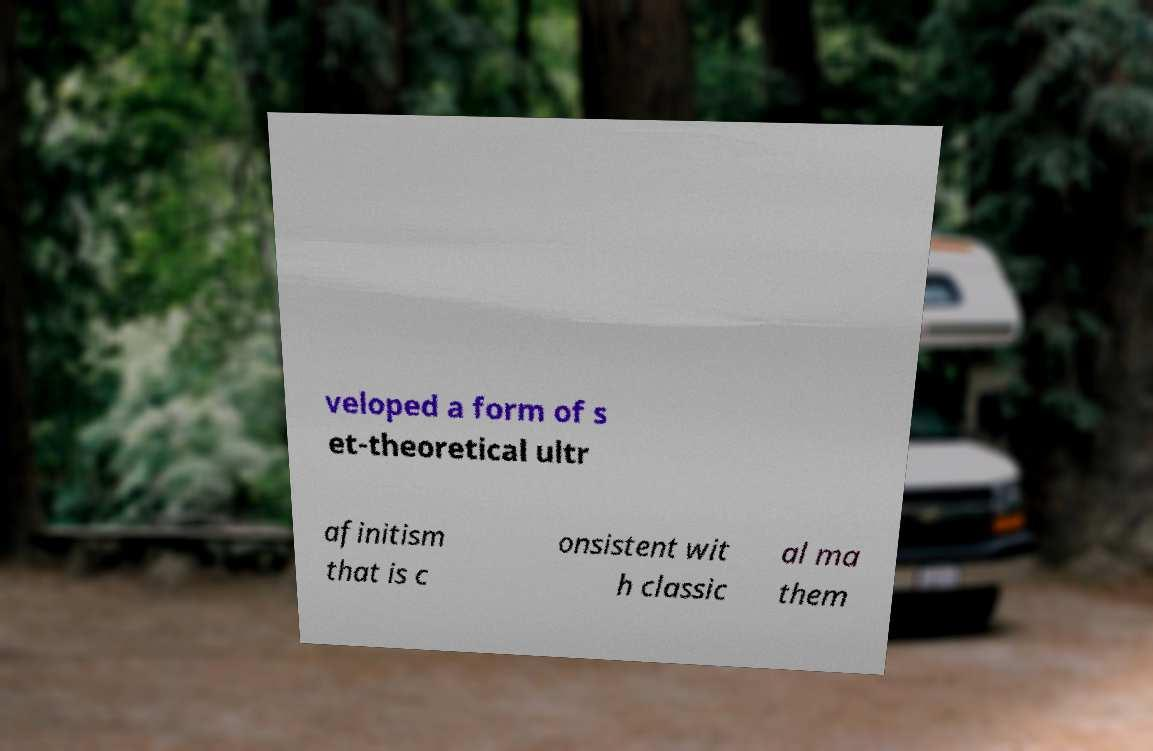Could you extract and type out the text from this image? veloped a form of s et-theoretical ultr afinitism that is c onsistent wit h classic al ma them 